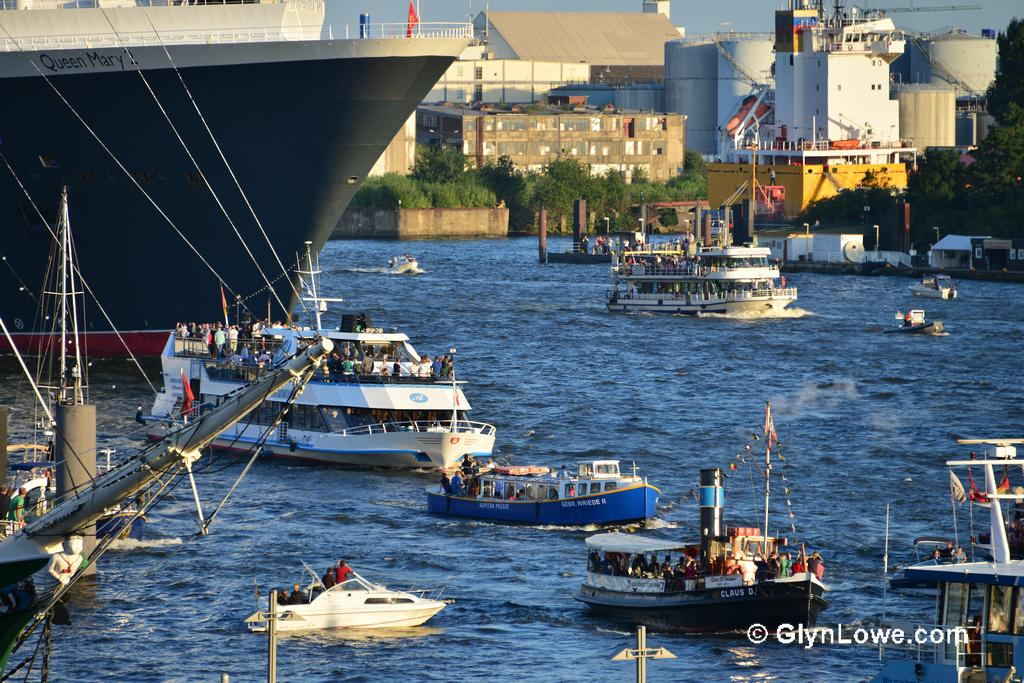What type of body of water is visible in the image? There is a sea in the image. What can be seen floating on the water in the image? There are ships in the water in the image. What structures are visible in the background of the image? There are buildings in the background of the image. What type of vegetation is present in the image? There are trees in the image. What type of throne can be seen in the image? There is no throne present in the image. What sound can be heard coming from the sea in the image? The image is silent, so no sound can be heard. 